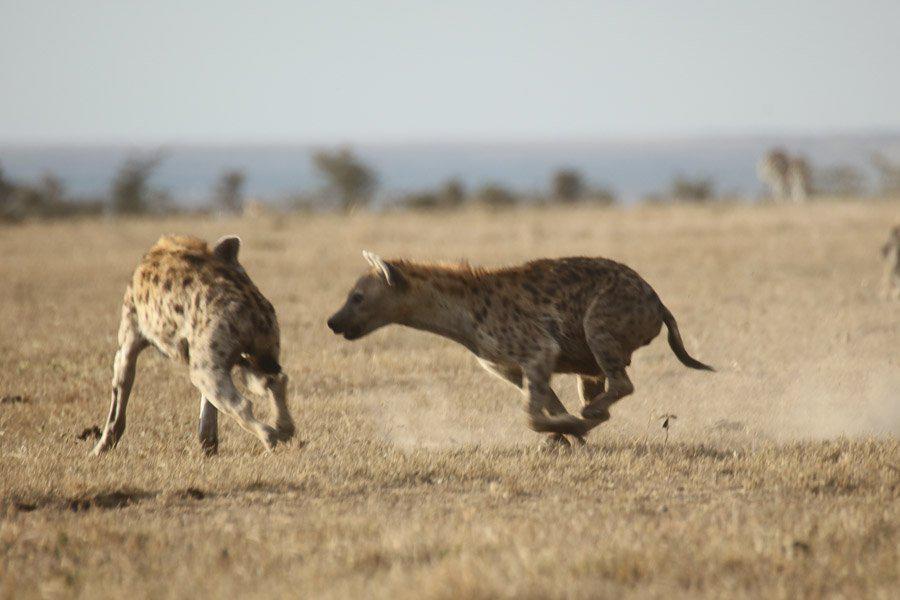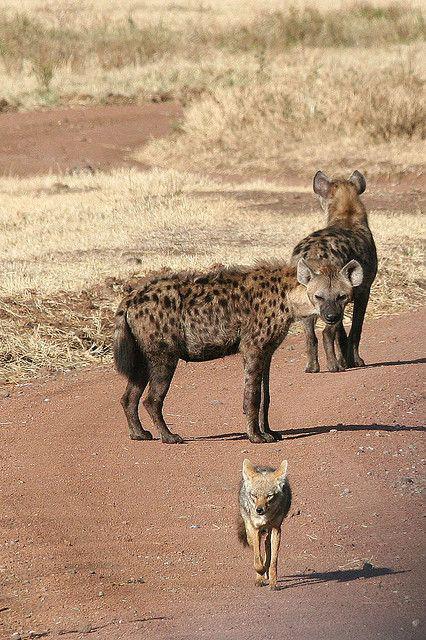The first image is the image on the left, the second image is the image on the right. For the images displayed, is the sentence "There are hyenas feasting on a dead animal." factually correct? Answer yes or no. No. The first image is the image on the left, the second image is the image on the right. Evaluate the accuracy of this statement regarding the images: "The right image includes at least one jackal near at least two spotted hyenas.". Is it true? Answer yes or no. Yes. 